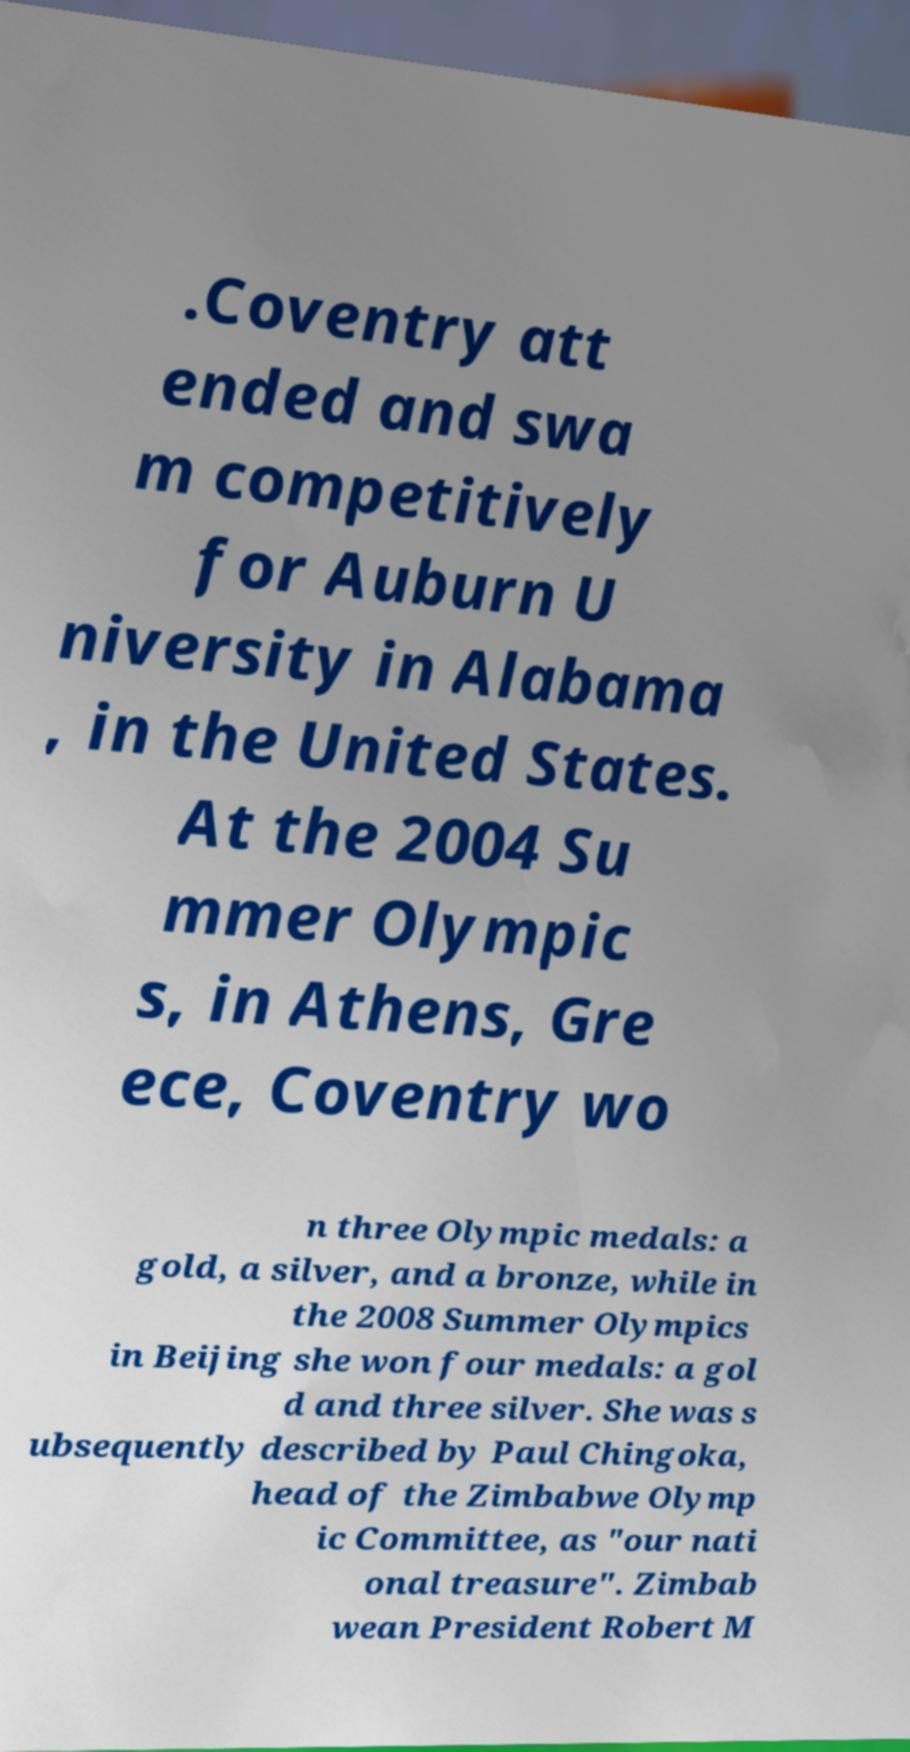Could you assist in decoding the text presented in this image and type it out clearly? .Coventry att ended and swa m competitively for Auburn U niversity in Alabama , in the United States. At the 2004 Su mmer Olympic s, in Athens, Gre ece, Coventry wo n three Olympic medals: a gold, a silver, and a bronze, while in the 2008 Summer Olympics in Beijing she won four medals: a gol d and three silver. She was s ubsequently described by Paul Chingoka, head of the Zimbabwe Olymp ic Committee, as "our nati onal treasure". Zimbab wean President Robert M 